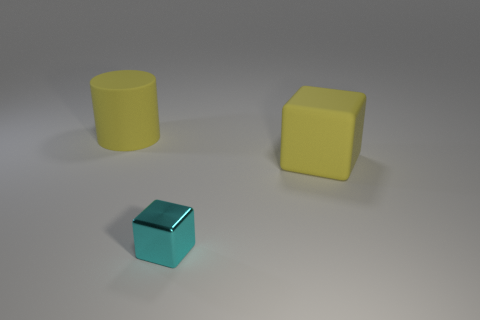Add 2 large rubber cylinders. How many objects exist? 5 Subtract all cylinders. How many objects are left? 2 Subtract all big yellow objects. Subtract all cyan objects. How many objects are left? 0 Add 3 tiny things. How many tiny things are left? 4 Add 1 tiny cyan cubes. How many tiny cyan cubes exist? 2 Subtract 1 cyan blocks. How many objects are left? 2 